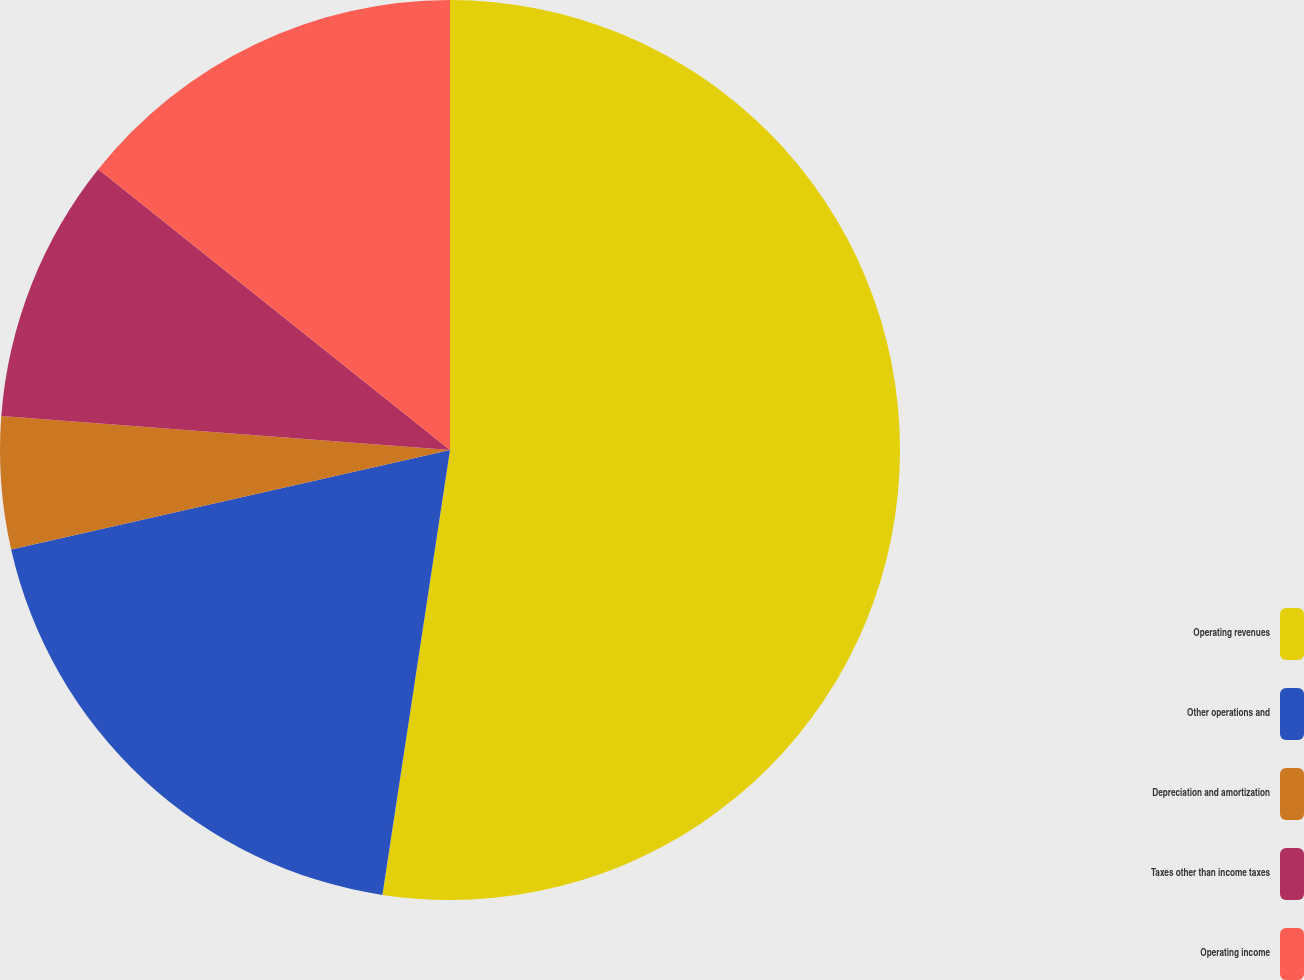Convert chart. <chart><loc_0><loc_0><loc_500><loc_500><pie_chart><fcel>Operating revenues<fcel>Other operations and<fcel>Depreciation and amortization<fcel>Taxes other than income taxes<fcel>Operating income<nl><fcel>52.4%<fcel>19.05%<fcel>4.75%<fcel>9.52%<fcel>14.28%<nl></chart> 